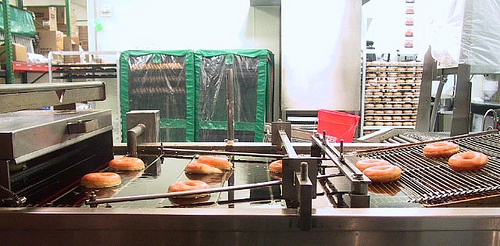Describe the objects in this image and their specific colors. I can see donut in lightyellow, white, darkgray, and tan tones, donut in lightyellow, black, tan, and maroon tones, donut in lightyellow, salmon, maroon, tan, and lightgray tones, donut in lightyellow, orange, maroon, brown, and tan tones, and donut in lightyellow, lavender, tan, brown, and salmon tones in this image. 